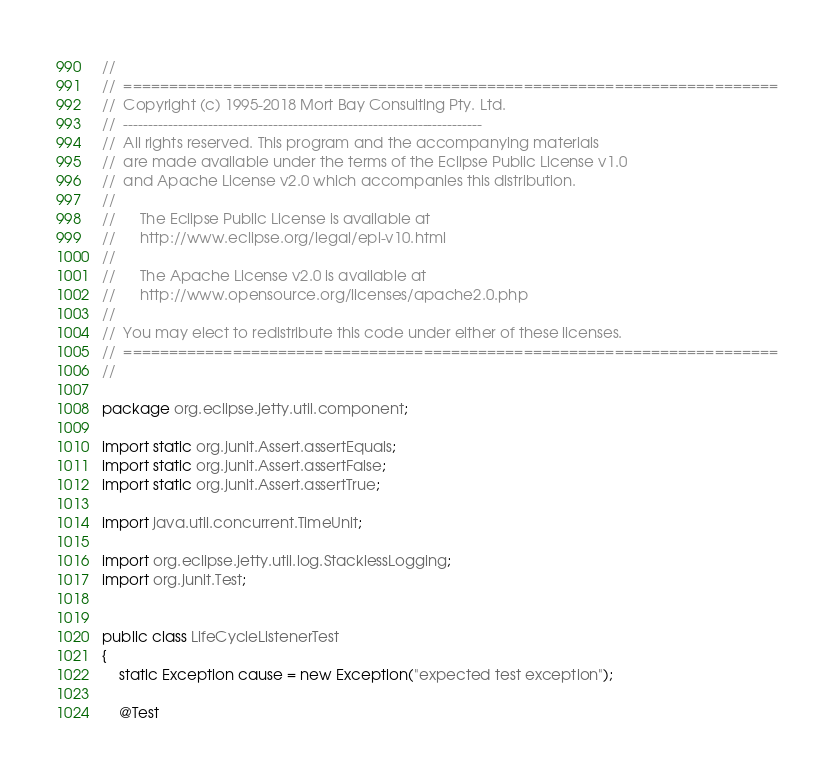Convert code to text. <code><loc_0><loc_0><loc_500><loc_500><_Java_>//
//  ========================================================================
//  Copyright (c) 1995-2018 Mort Bay Consulting Pty. Ltd.
//  ------------------------------------------------------------------------
//  All rights reserved. This program and the accompanying materials
//  are made available under the terms of the Eclipse Public License v1.0
//  and Apache License v2.0 which accompanies this distribution.
//
//      The Eclipse Public License is available at
//      http://www.eclipse.org/legal/epl-v10.html
//
//      The Apache License v2.0 is available at
//      http://www.opensource.org/licenses/apache2.0.php
//
//  You may elect to redistribute this code under either of these licenses.
//  ========================================================================
//

package org.eclipse.jetty.util.component;

import static org.junit.Assert.assertEquals;
import static org.junit.Assert.assertFalse;
import static org.junit.Assert.assertTrue;

import java.util.concurrent.TimeUnit;

import org.eclipse.jetty.util.log.StacklessLogging;
import org.junit.Test;


public class LifeCycleListenerTest
{
    static Exception cause = new Exception("expected test exception");

    @Test</code> 